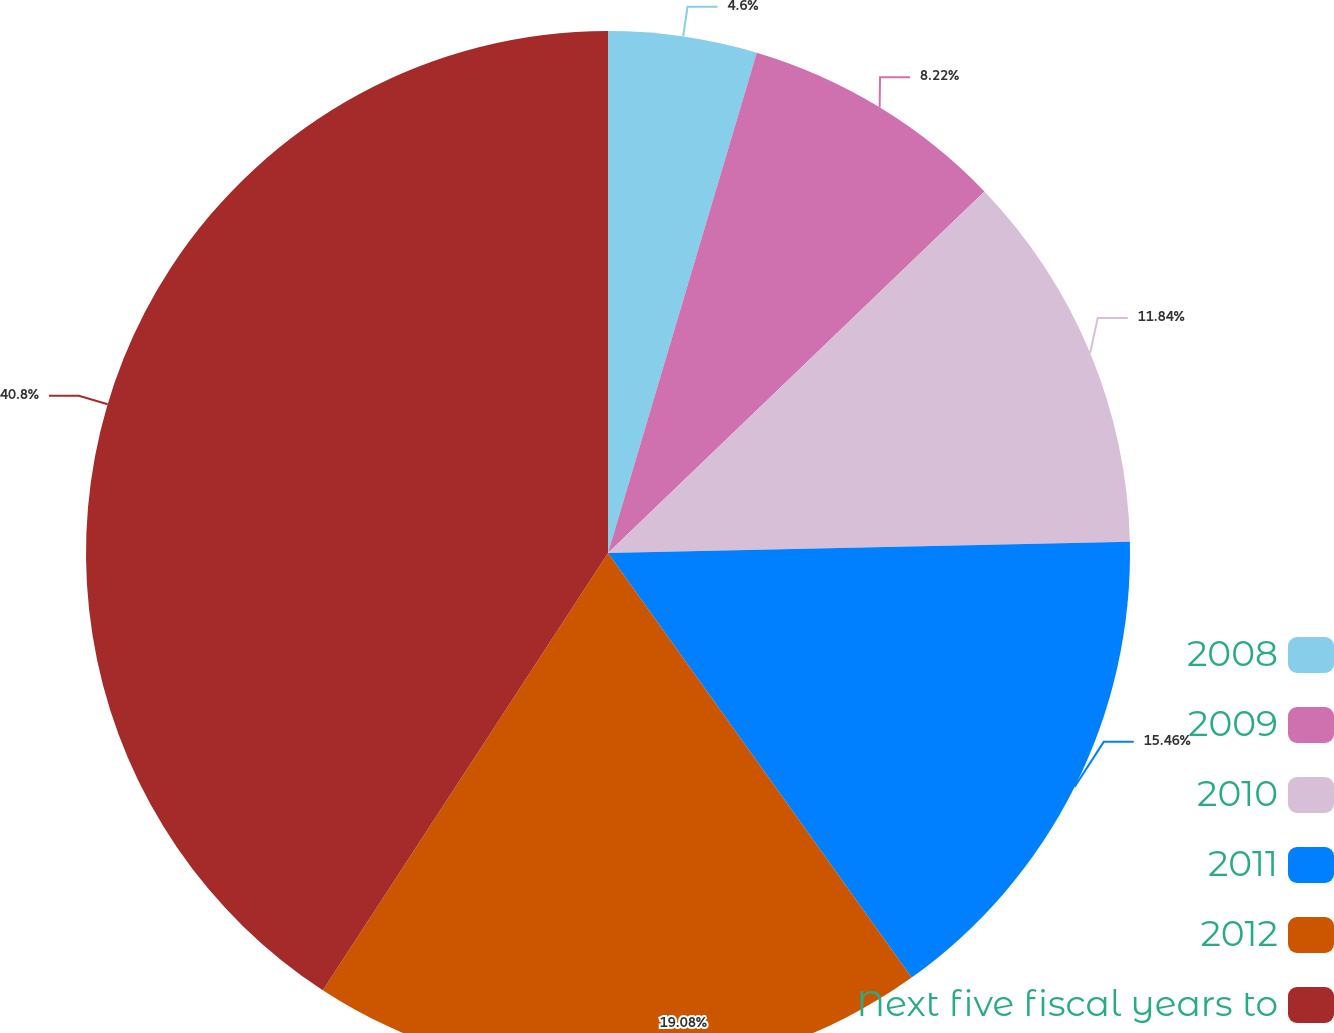<chart> <loc_0><loc_0><loc_500><loc_500><pie_chart><fcel>2008<fcel>2009<fcel>2010<fcel>2011<fcel>2012<fcel>Next five fiscal years to<nl><fcel>4.6%<fcel>8.22%<fcel>11.84%<fcel>15.46%<fcel>19.08%<fcel>40.8%<nl></chart> 